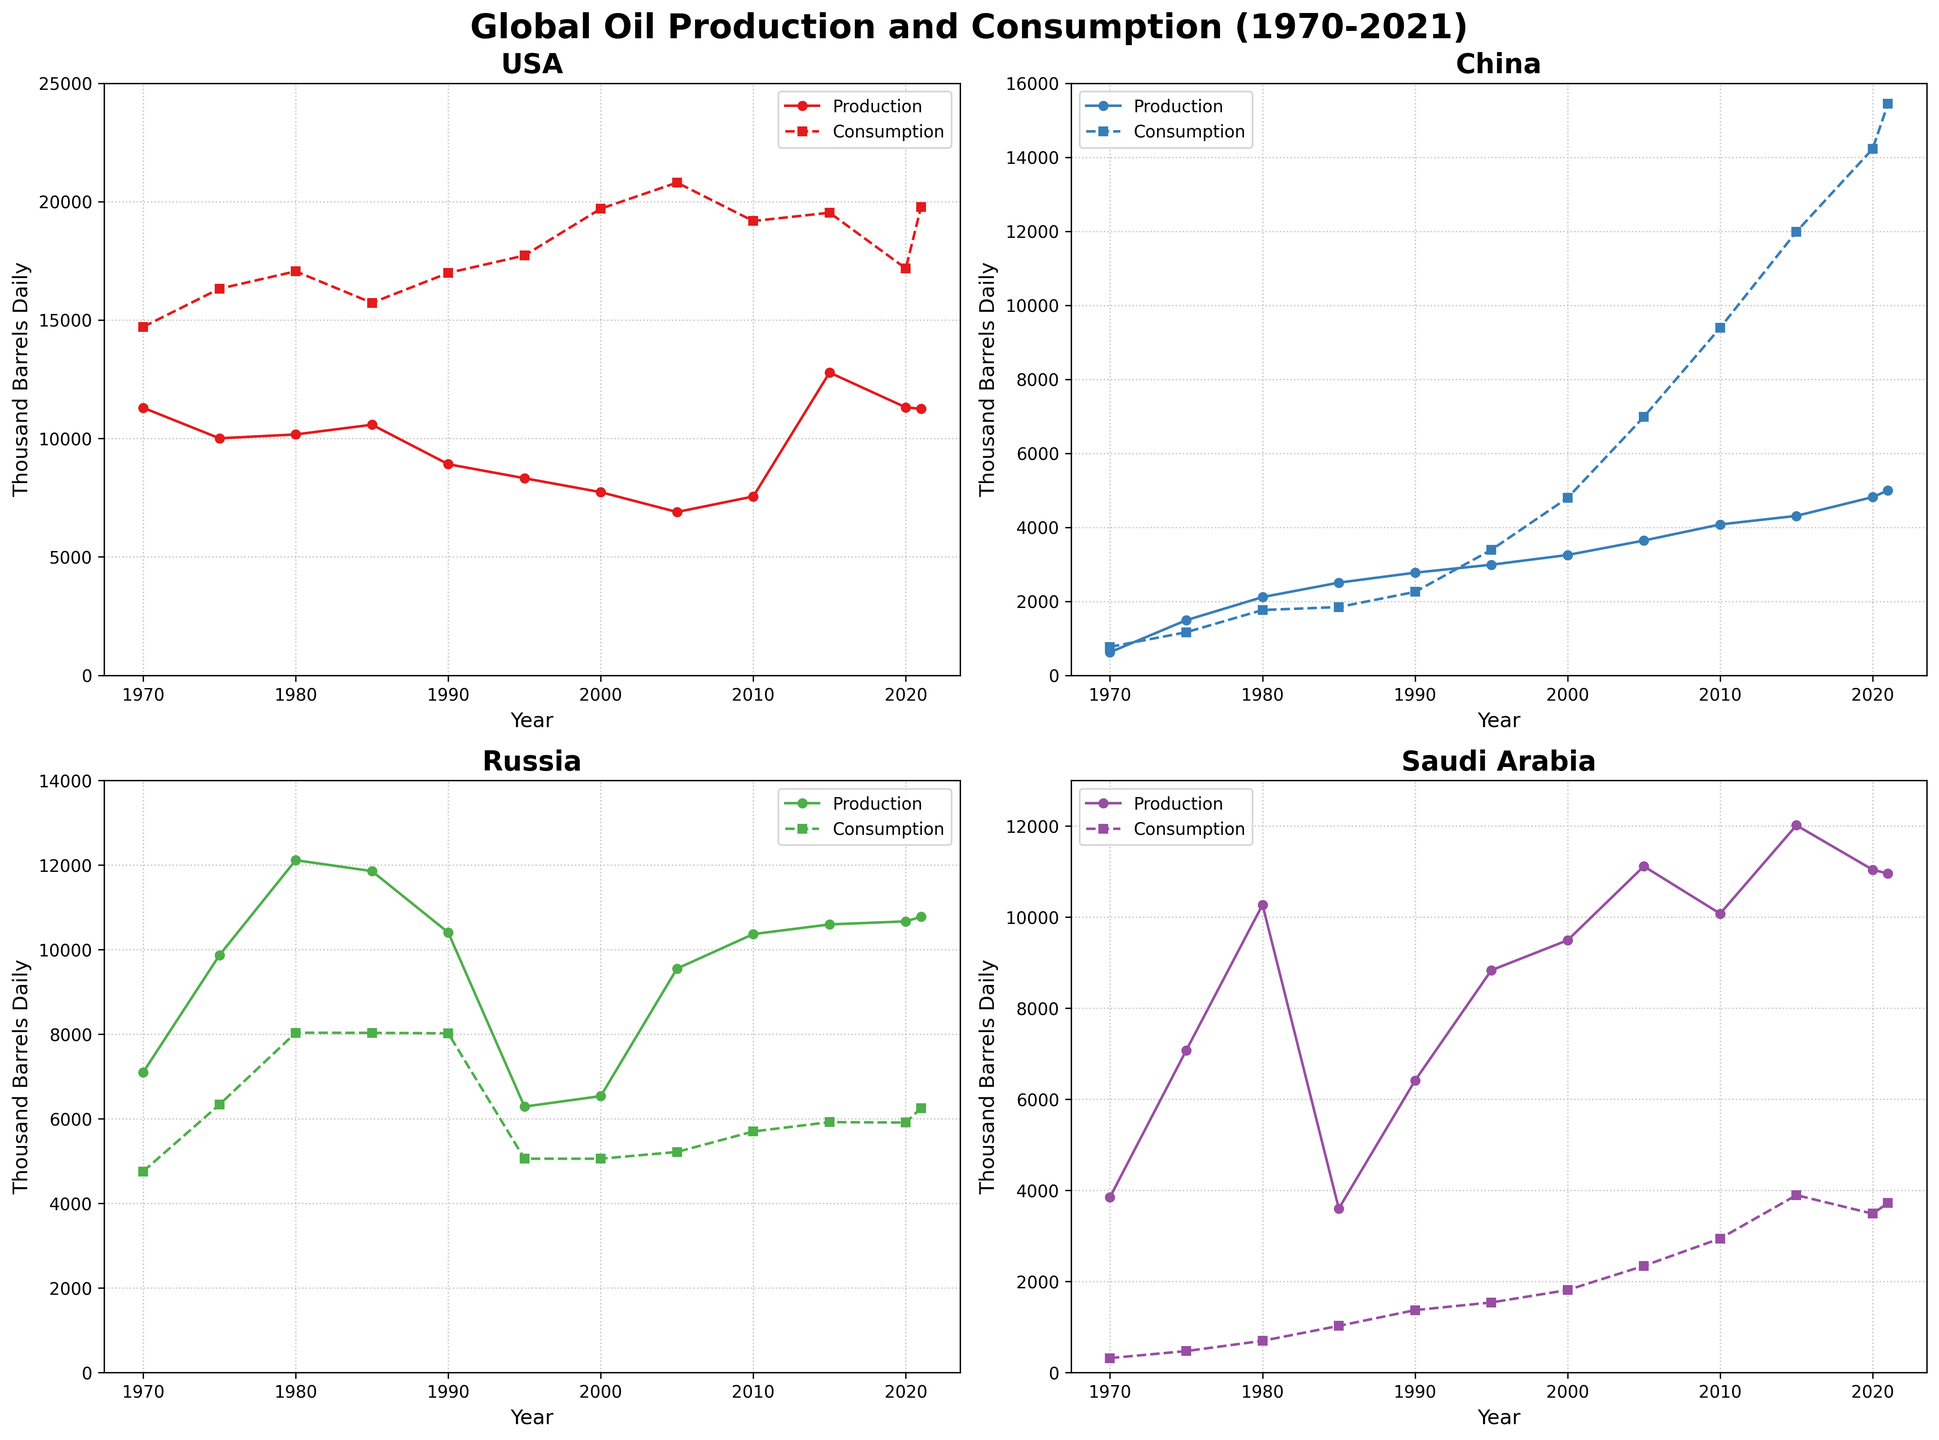What is the overall trend of oil production in the USA from 1970 to 2021? Observing the plot for the USA, the production starts around 11,297 in 1970, shows a decline until the early 2000s, and then rises again, peaking around 2015. The overall trend indicates a drop followed by an increase.
Answer: Drop then rise How did China's oil consumption change from 1970 to 2021? Examining China's subplot, the consumption starts at 770 in 1970 and continuously increases, reaching over 15,400 by 2021. The overall trend indicates a continuous rise in consumption.
Answer: Continuous rise In which year did Russia’s oil production surpass 12,000 thousand barrels daily? Reviewing Russia’s production line, it reaches above 12,000 thousand barrels daily by 1980 and 1985, and does so again around 2005.
Answer: 1980 By how much did Saudi Arabia's oil production exceed its consumption in 2020? In 2020, Saudi Arabia’s production is about 11,039 while its consumption is around 3,488. The difference is 11,039 - 3,488 = 7,551 thousand barrels daily.
Answer: 7,551 How does the oil consumption trend in the USA compare to that in China? The USA's consumption starts high, increases until around 2005, then slightly decreases and remains high. China's consumption starts low and steadily increases throughout the period. Overall, both countries' consumption trends are upward, but China’s rise is more consistent.
Answer: USA: high, then slight decrease; China: steady increase What is the average difference between consumption and production for Russia from 1970 to 2020? Over the given years, Russia shows close values for production and consumption, often below 2,000 difference. To get the average, sum the differences per year and divide by the number of years observed. Approximately 2000.
Answer: Approximately 2000 What year did Saudi Arabia's oil consumption first exceed 3000 thousand barrels daily? Saudi Arabia’s consumption crosses 3,000 after 2010, reaching above this mark between 2015 and 2020.
Answer: Between 2015-2020 Which country had the highest oil consumption in 2021? Observing all subplots, China’s consumption is the highest in 2021 at around 15,442 thousand barrels daily.
Answer: China Between Russia and China, which country showed a greater increase in production from 2000 to 2010? In the plot, Russia’s production increases from about 6,536 in 2000 to 10,366 in 2010, a rise of approximately 3,830. China’s production increases from about 3,252 to 4,077, a rise of about 825. Hence, Russia shows a greater increase.
Answer: Russia Which period shows the maximum difference between production and consumption for the USA? Comparing the differences, the largest gap appears from around 2005-2010, with production and consumption differences appearing most significant visually.
Answer: 2005-2010 